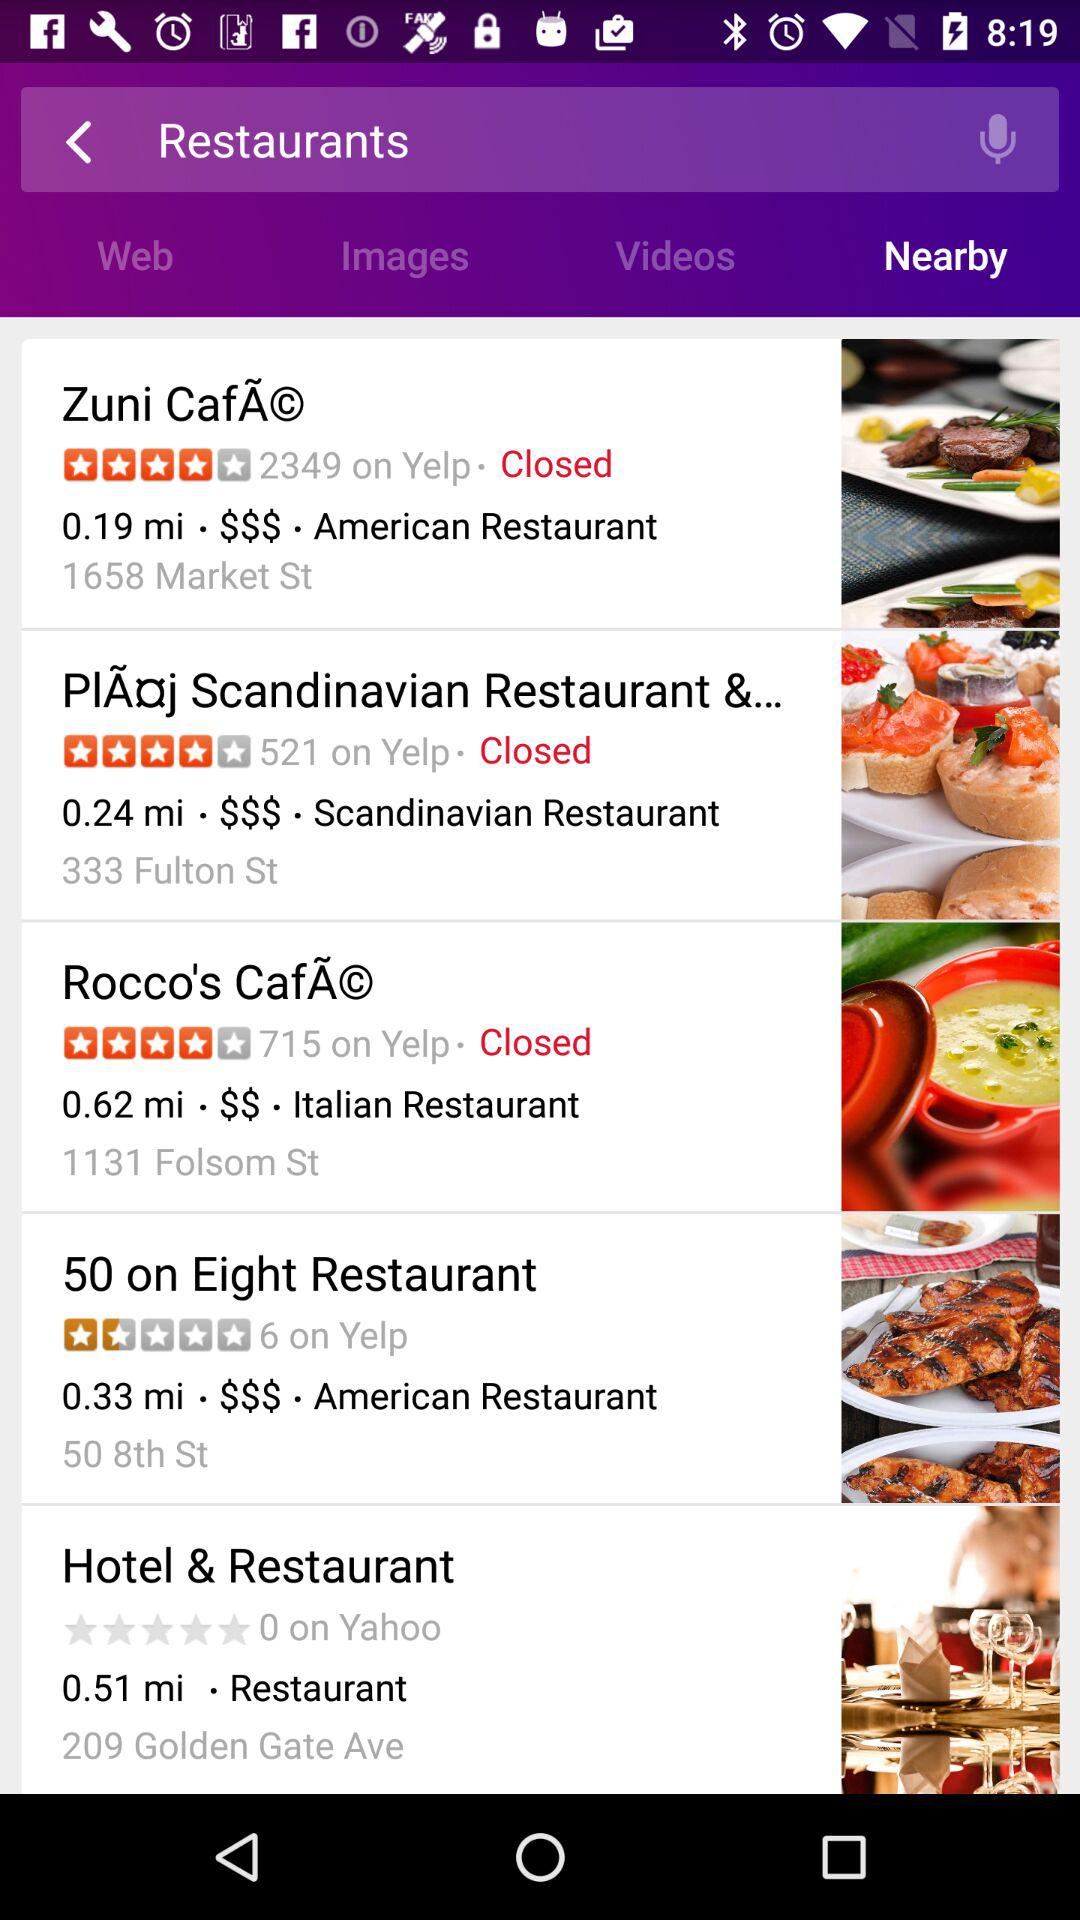How much time it take to reach "50 on Eight Restaurant "?
When the provided information is insufficient, respond with <no answer>. <no answer> 